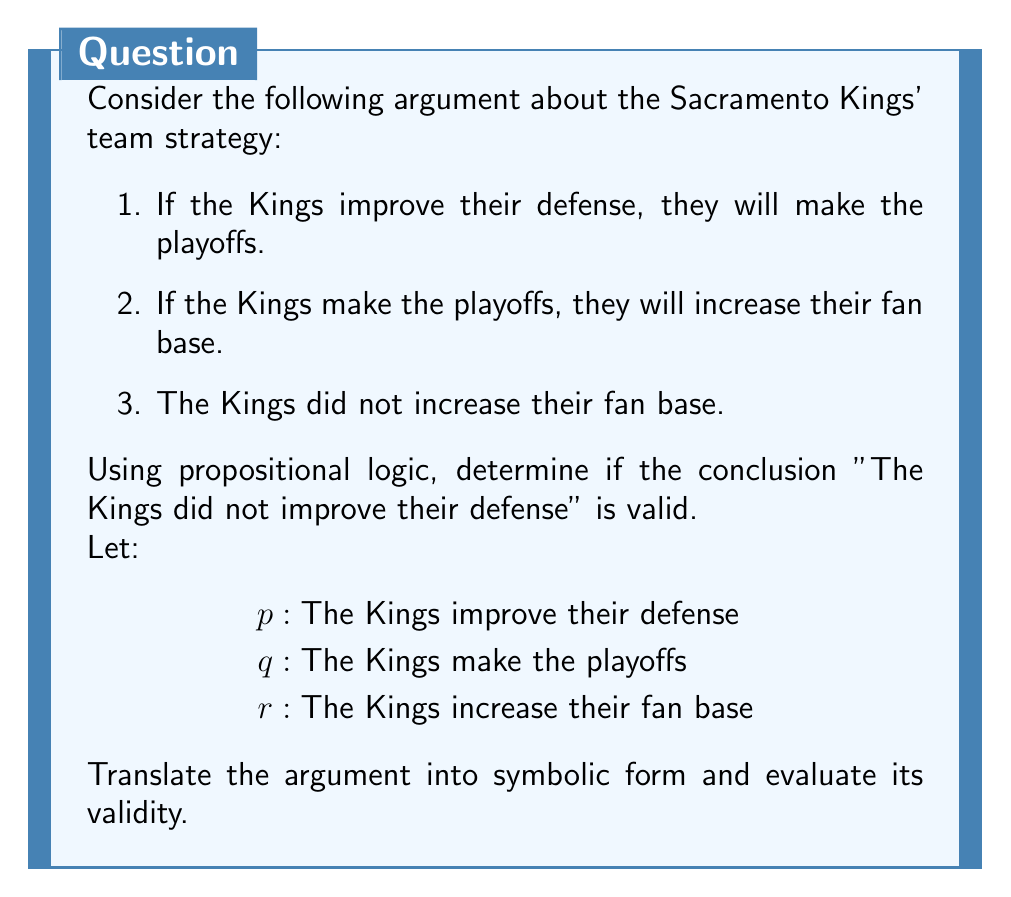Can you answer this question? Let's approach this step-by-step:

1) First, we translate the premises and conclusion into symbolic form:

   Premise 1: $p \rightarrow q$
   Premise 2: $q \rightarrow r$
   Premise 3: $\neg r$
   Conclusion: $\neg p$

2) The argument structure is:

   $$(p \rightarrow q) \land (q \rightarrow r) \land \neg r \therefore \neg p$$

3) To prove validity, we can use the method of contradiction. Assume the premises are true and the conclusion is false, then derive a contradiction.

4) Assume premises are true and conclusion is false:
   $(p \rightarrow q) \land (q \rightarrow r) \land \neg r \land p$

5) From $p$ and $(p \rightarrow q)$, we can deduce $q$ (Modus Ponens).

6) From $q$ and $(q \rightarrow r)$, we can deduce $r$ (Modus Ponens).

7) But we also have $\neg r$ from our premises.

8) $r \land \neg r$ is a contradiction.

9) Since we derived a contradiction from our assumptions, the original argument is valid. If the premises are true, the conclusion must be true.

This form of argument is known as Modus Tollens (denying the consequent):

$$(p \rightarrow q) \land \neg q \therefore \neg p$$

In our case, we have a chain of implications that leads to the same structure.
Answer: Valid 